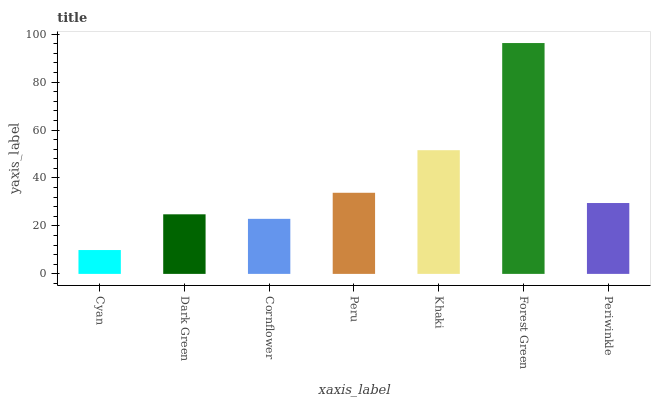Is Cyan the minimum?
Answer yes or no. Yes. Is Forest Green the maximum?
Answer yes or no. Yes. Is Dark Green the minimum?
Answer yes or no. No. Is Dark Green the maximum?
Answer yes or no. No. Is Dark Green greater than Cyan?
Answer yes or no. Yes. Is Cyan less than Dark Green?
Answer yes or no. Yes. Is Cyan greater than Dark Green?
Answer yes or no. No. Is Dark Green less than Cyan?
Answer yes or no. No. Is Periwinkle the high median?
Answer yes or no. Yes. Is Periwinkle the low median?
Answer yes or no. Yes. Is Khaki the high median?
Answer yes or no. No. Is Cornflower the low median?
Answer yes or no. No. 